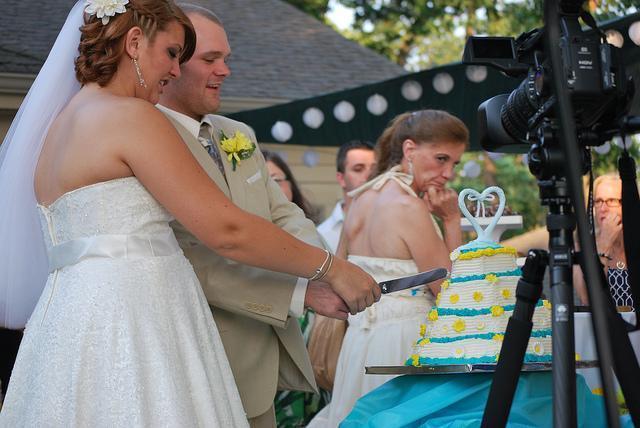How many tiers is the cake?
Give a very brief answer. 4. How many people can you see?
Give a very brief answer. 5. How many baby sheep are there in the image?
Give a very brief answer. 0. 